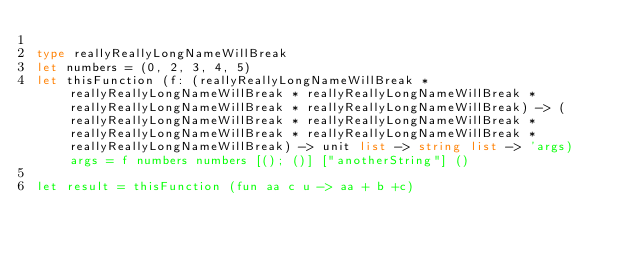<code> <loc_0><loc_0><loc_500><loc_500><_OCaml_>
type reallyReallyLongNameWillBreak
let numbers = (0, 2, 3, 4, 5)
let thisFunction (f: (reallyReallyLongNameWillBreak * reallyReallyLongNameWillBreak * reallyReallyLongNameWillBreak * reallyReallyLongNameWillBreak * reallyReallyLongNameWillBreak) -> (reallyReallyLongNameWillBreak * reallyReallyLongNameWillBreak * reallyReallyLongNameWillBreak * reallyReallyLongNameWillBreak * reallyReallyLongNameWillBreak) -> unit list -> string list -> 'args) args = f numbers numbers [(); ()] ["anotherString"] ()

let result = thisFunction (fun aa c u -> aa + b +c)








</code> 